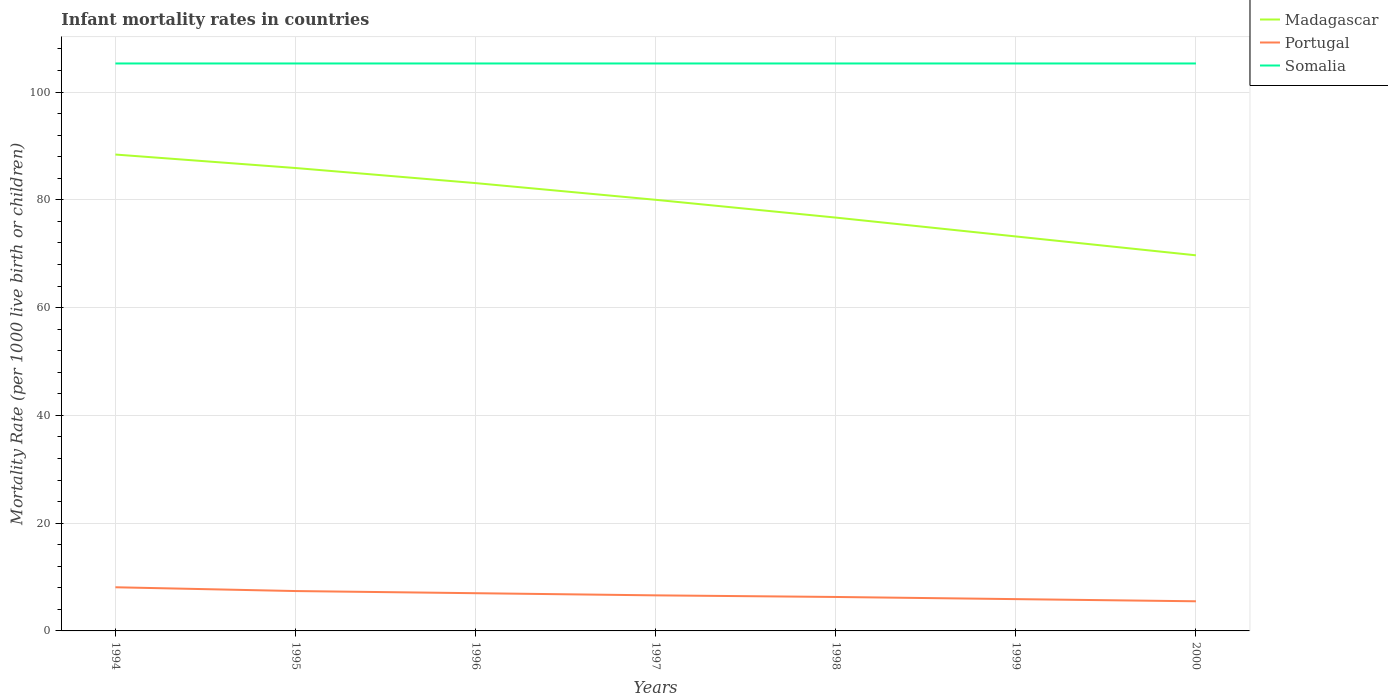Does the line corresponding to Somalia intersect with the line corresponding to Portugal?
Make the answer very short. No. Is the number of lines equal to the number of legend labels?
Offer a very short reply. Yes. In which year was the infant mortality rate in Madagascar maximum?
Give a very brief answer. 2000. What is the total infant mortality rate in Madagascar in the graph?
Ensure brevity in your answer.  6.4. What is the difference between the highest and the second highest infant mortality rate in Madagascar?
Your response must be concise. 18.7. What is the difference between the highest and the lowest infant mortality rate in Madagascar?
Ensure brevity in your answer.  4. How many lines are there?
Your answer should be very brief. 3. How many years are there in the graph?
Your answer should be very brief. 7. Does the graph contain any zero values?
Provide a succinct answer. No. Does the graph contain grids?
Your answer should be very brief. Yes. How are the legend labels stacked?
Make the answer very short. Vertical. What is the title of the graph?
Provide a succinct answer. Infant mortality rates in countries. What is the label or title of the X-axis?
Your response must be concise. Years. What is the label or title of the Y-axis?
Offer a very short reply. Mortality Rate (per 1000 live birth or children). What is the Mortality Rate (per 1000 live birth or children) of Madagascar in 1994?
Make the answer very short. 88.4. What is the Mortality Rate (per 1000 live birth or children) of Portugal in 1994?
Your answer should be compact. 8.1. What is the Mortality Rate (per 1000 live birth or children) of Somalia in 1994?
Offer a very short reply. 105.3. What is the Mortality Rate (per 1000 live birth or children) in Madagascar in 1995?
Your response must be concise. 85.9. What is the Mortality Rate (per 1000 live birth or children) of Portugal in 1995?
Your response must be concise. 7.4. What is the Mortality Rate (per 1000 live birth or children) in Somalia in 1995?
Your answer should be compact. 105.3. What is the Mortality Rate (per 1000 live birth or children) in Madagascar in 1996?
Your answer should be compact. 83.1. What is the Mortality Rate (per 1000 live birth or children) of Somalia in 1996?
Make the answer very short. 105.3. What is the Mortality Rate (per 1000 live birth or children) of Madagascar in 1997?
Make the answer very short. 80. What is the Mortality Rate (per 1000 live birth or children) in Somalia in 1997?
Give a very brief answer. 105.3. What is the Mortality Rate (per 1000 live birth or children) of Madagascar in 1998?
Offer a very short reply. 76.7. What is the Mortality Rate (per 1000 live birth or children) of Somalia in 1998?
Provide a succinct answer. 105.3. What is the Mortality Rate (per 1000 live birth or children) of Madagascar in 1999?
Provide a succinct answer. 73.2. What is the Mortality Rate (per 1000 live birth or children) in Portugal in 1999?
Your answer should be compact. 5.9. What is the Mortality Rate (per 1000 live birth or children) of Somalia in 1999?
Provide a short and direct response. 105.3. What is the Mortality Rate (per 1000 live birth or children) in Madagascar in 2000?
Provide a short and direct response. 69.7. What is the Mortality Rate (per 1000 live birth or children) of Somalia in 2000?
Provide a short and direct response. 105.3. Across all years, what is the maximum Mortality Rate (per 1000 live birth or children) in Madagascar?
Keep it short and to the point. 88.4. Across all years, what is the maximum Mortality Rate (per 1000 live birth or children) in Somalia?
Your answer should be very brief. 105.3. Across all years, what is the minimum Mortality Rate (per 1000 live birth or children) in Madagascar?
Make the answer very short. 69.7. Across all years, what is the minimum Mortality Rate (per 1000 live birth or children) of Somalia?
Your response must be concise. 105.3. What is the total Mortality Rate (per 1000 live birth or children) of Madagascar in the graph?
Your response must be concise. 557. What is the total Mortality Rate (per 1000 live birth or children) of Portugal in the graph?
Keep it short and to the point. 46.8. What is the total Mortality Rate (per 1000 live birth or children) of Somalia in the graph?
Provide a short and direct response. 737.1. What is the difference between the Mortality Rate (per 1000 live birth or children) of Somalia in 1994 and that in 1997?
Provide a succinct answer. 0. What is the difference between the Mortality Rate (per 1000 live birth or children) in Portugal in 1994 and that in 1998?
Ensure brevity in your answer.  1.8. What is the difference between the Mortality Rate (per 1000 live birth or children) of Somalia in 1994 and that in 1998?
Ensure brevity in your answer.  0. What is the difference between the Mortality Rate (per 1000 live birth or children) in Portugal in 1994 and that in 2000?
Give a very brief answer. 2.6. What is the difference between the Mortality Rate (per 1000 live birth or children) of Madagascar in 1995 and that in 1996?
Ensure brevity in your answer.  2.8. What is the difference between the Mortality Rate (per 1000 live birth or children) in Portugal in 1995 and that in 1996?
Your response must be concise. 0.4. What is the difference between the Mortality Rate (per 1000 live birth or children) of Somalia in 1995 and that in 1996?
Your answer should be compact. 0. What is the difference between the Mortality Rate (per 1000 live birth or children) of Portugal in 1995 and that in 1997?
Ensure brevity in your answer.  0.8. What is the difference between the Mortality Rate (per 1000 live birth or children) of Somalia in 1995 and that in 1998?
Your response must be concise. 0. What is the difference between the Mortality Rate (per 1000 live birth or children) in Madagascar in 1995 and that in 1999?
Your answer should be compact. 12.7. What is the difference between the Mortality Rate (per 1000 live birth or children) of Portugal in 1995 and that in 1999?
Make the answer very short. 1.5. What is the difference between the Mortality Rate (per 1000 live birth or children) in Portugal in 1996 and that in 1997?
Your response must be concise. 0.4. What is the difference between the Mortality Rate (per 1000 live birth or children) in Portugal in 1996 and that in 1998?
Ensure brevity in your answer.  0.7. What is the difference between the Mortality Rate (per 1000 live birth or children) of Portugal in 1996 and that in 1999?
Make the answer very short. 1.1. What is the difference between the Mortality Rate (per 1000 live birth or children) in Madagascar in 1996 and that in 2000?
Give a very brief answer. 13.4. What is the difference between the Mortality Rate (per 1000 live birth or children) in Portugal in 1996 and that in 2000?
Provide a succinct answer. 1.5. What is the difference between the Mortality Rate (per 1000 live birth or children) of Portugal in 1997 and that in 1998?
Keep it short and to the point. 0.3. What is the difference between the Mortality Rate (per 1000 live birth or children) in Madagascar in 1997 and that in 1999?
Your response must be concise. 6.8. What is the difference between the Mortality Rate (per 1000 live birth or children) of Portugal in 1997 and that in 1999?
Provide a succinct answer. 0.7. What is the difference between the Mortality Rate (per 1000 live birth or children) of Somalia in 1997 and that in 1999?
Offer a very short reply. 0. What is the difference between the Mortality Rate (per 1000 live birth or children) of Madagascar in 1997 and that in 2000?
Your answer should be compact. 10.3. What is the difference between the Mortality Rate (per 1000 live birth or children) of Portugal in 1997 and that in 2000?
Your answer should be very brief. 1.1. What is the difference between the Mortality Rate (per 1000 live birth or children) of Portugal in 1998 and that in 1999?
Keep it short and to the point. 0.4. What is the difference between the Mortality Rate (per 1000 live birth or children) in Portugal in 1998 and that in 2000?
Your response must be concise. 0.8. What is the difference between the Mortality Rate (per 1000 live birth or children) of Somalia in 1998 and that in 2000?
Keep it short and to the point. 0. What is the difference between the Mortality Rate (per 1000 live birth or children) in Madagascar in 1999 and that in 2000?
Offer a very short reply. 3.5. What is the difference between the Mortality Rate (per 1000 live birth or children) in Somalia in 1999 and that in 2000?
Give a very brief answer. 0. What is the difference between the Mortality Rate (per 1000 live birth or children) of Madagascar in 1994 and the Mortality Rate (per 1000 live birth or children) of Portugal in 1995?
Ensure brevity in your answer.  81. What is the difference between the Mortality Rate (per 1000 live birth or children) of Madagascar in 1994 and the Mortality Rate (per 1000 live birth or children) of Somalia in 1995?
Ensure brevity in your answer.  -16.9. What is the difference between the Mortality Rate (per 1000 live birth or children) of Portugal in 1994 and the Mortality Rate (per 1000 live birth or children) of Somalia in 1995?
Your response must be concise. -97.2. What is the difference between the Mortality Rate (per 1000 live birth or children) of Madagascar in 1994 and the Mortality Rate (per 1000 live birth or children) of Portugal in 1996?
Offer a terse response. 81.4. What is the difference between the Mortality Rate (per 1000 live birth or children) in Madagascar in 1994 and the Mortality Rate (per 1000 live birth or children) in Somalia in 1996?
Give a very brief answer. -16.9. What is the difference between the Mortality Rate (per 1000 live birth or children) in Portugal in 1994 and the Mortality Rate (per 1000 live birth or children) in Somalia in 1996?
Offer a very short reply. -97.2. What is the difference between the Mortality Rate (per 1000 live birth or children) of Madagascar in 1994 and the Mortality Rate (per 1000 live birth or children) of Portugal in 1997?
Offer a very short reply. 81.8. What is the difference between the Mortality Rate (per 1000 live birth or children) in Madagascar in 1994 and the Mortality Rate (per 1000 live birth or children) in Somalia in 1997?
Your answer should be compact. -16.9. What is the difference between the Mortality Rate (per 1000 live birth or children) in Portugal in 1994 and the Mortality Rate (per 1000 live birth or children) in Somalia in 1997?
Your answer should be compact. -97.2. What is the difference between the Mortality Rate (per 1000 live birth or children) of Madagascar in 1994 and the Mortality Rate (per 1000 live birth or children) of Portugal in 1998?
Your answer should be compact. 82.1. What is the difference between the Mortality Rate (per 1000 live birth or children) of Madagascar in 1994 and the Mortality Rate (per 1000 live birth or children) of Somalia in 1998?
Ensure brevity in your answer.  -16.9. What is the difference between the Mortality Rate (per 1000 live birth or children) in Portugal in 1994 and the Mortality Rate (per 1000 live birth or children) in Somalia in 1998?
Offer a terse response. -97.2. What is the difference between the Mortality Rate (per 1000 live birth or children) of Madagascar in 1994 and the Mortality Rate (per 1000 live birth or children) of Portugal in 1999?
Offer a terse response. 82.5. What is the difference between the Mortality Rate (per 1000 live birth or children) of Madagascar in 1994 and the Mortality Rate (per 1000 live birth or children) of Somalia in 1999?
Provide a short and direct response. -16.9. What is the difference between the Mortality Rate (per 1000 live birth or children) of Portugal in 1994 and the Mortality Rate (per 1000 live birth or children) of Somalia in 1999?
Ensure brevity in your answer.  -97.2. What is the difference between the Mortality Rate (per 1000 live birth or children) of Madagascar in 1994 and the Mortality Rate (per 1000 live birth or children) of Portugal in 2000?
Offer a terse response. 82.9. What is the difference between the Mortality Rate (per 1000 live birth or children) of Madagascar in 1994 and the Mortality Rate (per 1000 live birth or children) of Somalia in 2000?
Your response must be concise. -16.9. What is the difference between the Mortality Rate (per 1000 live birth or children) of Portugal in 1994 and the Mortality Rate (per 1000 live birth or children) of Somalia in 2000?
Your answer should be very brief. -97.2. What is the difference between the Mortality Rate (per 1000 live birth or children) in Madagascar in 1995 and the Mortality Rate (per 1000 live birth or children) in Portugal in 1996?
Offer a terse response. 78.9. What is the difference between the Mortality Rate (per 1000 live birth or children) of Madagascar in 1995 and the Mortality Rate (per 1000 live birth or children) of Somalia in 1996?
Your answer should be very brief. -19.4. What is the difference between the Mortality Rate (per 1000 live birth or children) in Portugal in 1995 and the Mortality Rate (per 1000 live birth or children) in Somalia in 1996?
Your answer should be very brief. -97.9. What is the difference between the Mortality Rate (per 1000 live birth or children) in Madagascar in 1995 and the Mortality Rate (per 1000 live birth or children) in Portugal in 1997?
Provide a succinct answer. 79.3. What is the difference between the Mortality Rate (per 1000 live birth or children) of Madagascar in 1995 and the Mortality Rate (per 1000 live birth or children) of Somalia in 1997?
Offer a very short reply. -19.4. What is the difference between the Mortality Rate (per 1000 live birth or children) in Portugal in 1995 and the Mortality Rate (per 1000 live birth or children) in Somalia in 1997?
Provide a short and direct response. -97.9. What is the difference between the Mortality Rate (per 1000 live birth or children) in Madagascar in 1995 and the Mortality Rate (per 1000 live birth or children) in Portugal in 1998?
Offer a very short reply. 79.6. What is the difference between the Mortality Rate (per 1000 live birth or children) in Madagascar in 1995 and the Mortality Rate (per 1000 live birth or children) in Somalia in 1998?
Make the answer very short. -19.4. What is the difference between the Mortality Rate (per 1000 live birth or children) in Portugal in 1995 and the Mortality Rate (per 1000 live birth or children) in Somalia in 1998?
Provide a succinct answer. -97.9. What is the difference between the Mortality Rate (per 1000 live birth or children) of Madagascar in 1995 and the Mortality Rate (per 1000 live birth or children) of Portugal in 1999?
Provide a short and direct response. 80. What is the difference between the Mortality Rate (per 1000 live birth or children) in Madagascar in 1995 and the Mortality Rate (per 1000 live birth or children) in Somalia in 1999?
Your response must be concise. -19.4. What is the difference between the Mortality Rate (per 1000 live birth or children) in Portugal in 1995 and the Mortality Rate (per 1000 live birth or children) in Somalia in 1999?
Provide a succinct answer. -97.9. What is the difference between the Mortality Rate (per 1000 live birth or children) of Madagascar in 1995 and the Mortality Rate (per 1000 live birth or children) of Portugal in 2000?
Give a very brief answer. 80.4. What is the difference between the Mortality Rate (per 1000 live birth or children) in Madagascar in 1995 and the Mortality Rate (per 1000 live birth or children) in Somalia in 2000?
Give a very brief answer. -19.4. What is the difference between the Mortality Rate (per 1000 live birth or children) in Portugal in 1995 and the Mortality Rate (per 1000 live birth or children) in Somalia in 2000?
Provide a short and direct response. -97.9. What is the difference between the Mortality Rate (per 1000 live birth or children) in Madagascar in 1996 and the Mortality Rate (per 1000 live birth or children) in Portugal in 1997?
Ensure brevity in your answer.  76.5. What is the difference between the Mortality Rate (per 1000 live birth or children) in Madagascar in 1996 and the Mortality Rate (per 1000 live birth or children) in Somalia in 1997?
Your response must be concise. -22.2. What is the difference between the Mortality Rate (per 1000 live birth or children) in Portugal in 1996 and the Mortality Rate (per 1000 live birth or children) in Somalia in 1997?
Give a very brief answer. -98.3. What is the difference between the Mortality Rate (per 1000 live birth or children) of Madagascar in 1996 and the Mortality Rate (per 1000 live birth or children) of Portugal in 1998?
Your answer should be very brief. 76.8. What is the difference between the Mortality Rate (per 1000 live birth or children) in Madagascar in 1996 and the Mortality Rate (per 1000 live birth or children) in Somalia in 1998?
Provide a short and direct response. -22.2. What is the difference between the Mortality Rate (per 1000 live birth or children) in Portugal in 1996 and the Mortality Rate (per 1000 live birth or children) in Somalia in 1998?
Your answer should be compact. -98.3. What is the difference between the Mortality Rate (per 1000 live birth or children) in Madagascar in 1996 and the Mortality Rate (per 1000 live birth or children) in Portugal in 1999?
Give a very brief answer. 77.2. What is the difference between the Mortality Rate (per 1000 live birth or children) in Madagascar in 1996 and the Mortality Rate (per 1000 live birth or children) in Somalia in 1999?
Make the answer very short. -22.2. What is the difference between the Mortality Rate (per 1000 live birth or children) of Portugal in 1996 and the Mortality Rate (per 1000 live birth or children) of Somalia in 1999?
Your answer should be compact. -98.3. What is the difference between the Mortality Rate (per 1000 live birth or children) in Madagascar in 1996 and the Mortality Rate (per 1000 live birth or children) in Portugal in 2000?
Make the answer very short. 77.6. What is the difference between the Mortality Rate (per 1000 live birth or children) of Madagascar in 1996 and the Mortality Rate (per 1000 live birth or children) of Somalia in 2000?
Your answer should be compact. -22.2. What is the difference between the Mortality Rate (per 1000 live birth or children) in Portugal in 1996 and the Mortality Rate (per 1000 live birth or children) in Somalia in 2000?
Ensure brevity in your answer.  -98.3. What is the difference between the Mortality Rate (per 1000 live birth or children) of Madagascar in 1997 and the Mortality Rate (per 1000 live birth or children) of Portugal in 1998?
Ensure brevity in your answer.  73.7. What is the difference between the Mortality Rate (per 1000 live birth or children) of Madagascar in 1997 and the Mortality Rate (per 1000 live birth or children) of Somalia in 1998?
Keep it short and to the point. -25.3. What is the difference between the Mortality Rate (per 1000 live birth or children) in Portugal in 1997 and the Mortality Rate (per 1000 live birth or children) in Somalia in 1998?
Offer a terse response. -98.7. What is the difference between the Mortality Rate (per 1000 live birth or children) of Madagascar in 1997 and the Mortality Rate (per 1000 live birth or children) of Portugal in 1999?
Your answer should be compact. 74.1. What is the difference between the Mortality Rate (per 1000 live birth or children) of Madagascar in 1997 and the Mortality Rate (per 1000 live birth or children) of Somalia in 1999?
Offer a terse response. -25.3. What is the difference between the Mortality Rate (per 1000 live birth or children) of Portugal in 1997 and the Mortality Rate (per 1000 live birth or children) of Somalia in 1999?
Offer a very short reply. -98.7. What is the difference between the Mortality Rate (per 1000 live birth or children) in Madagascar in 1997 and the Mortality Rate (per 1000 live birth or children) in Portugal in 2000?
Your answer should be very brief. 74.5. What is the difference between the Mortality Rate (per 1000 live birth or children) of Madagascar in 1997 and the Mortality Rate (per 1000 live birth or children) of Somalia in 2000?
Offer a very short reply. -25.3. What is the difference between the Mortality Rate (per 1000 live birth or children) in Portugal in 1997 and the Mortality Rate (per 1000 live birth or children) in Somalia in 2000?
Your answer should be compact. -98.7. What is the difference between the Mortality Rate (per 1000 live birth or children) in Madagascar in 1998 and the Mortality Rate (per 1000 live birth or children) in Portugal in 1999?
Offer a very short reply. 70.8. What is the difference between the Mortality Rate (per 1000 live birth or children) in Madagascar in 1998 and the Mortality Rate (per 1000 live birth or children) in Somalia in 1999?
Offer a terse response. -28.6. What is the difference between the Mortality Rate (per 1000 live birth or children) in Portugal in 1998 and the Mortality Rate (per 1000 live birth or children) in Somalia in 1999?
Offer a terse response. -99. What is the difference between the Mortality Rate (per 1000 live birth or children) of Madagascar in 1998 and the Mortality Rate (per 1000 live birth or children) of Portugal in 2000?
Give a very brief answer. 71.2. What is the difference between the Mortality Rate (per 1000 live birth or children) in Madagascar in 1998 and the Mortality Rate (per 1000 live birth or children) in Somalia in 2000?
Your answer should be compact. -28.6. What is the difference between the Mortality Rate (per 1000 live birth or children) of Portugal in 1998 and the Mortality Rate (per 1000 live birth or children) of Somalia in 2000?
Your response must be concise. -99. What is the difference between the Mortality Rate (per 1000 live birth or children) of Madagascar in 1999 and the Mortality Rate (per 1000 live birth or children) of Portugal in 2000?
Offer a terse response. 67.7. What is the difference between the Mortality Rate (per 1000 live birth or children) of Madagascar in 1999 and the Mortality Rate (per 1000 live birth or children) of Somalia in 2000?
Your answer should be very brief. -32.1. What is the difference between the Mortality Rate (per 1000 live birth or children) in Portugal in 1999 and the Mortality Rate (per 1000 live birth or children) in Somalia in 2000?
Your answer should be compact. -99.4. What is the average Mortality Rate (per 1000 live birth or children) in Madagascar per year?
Make the answer very short. 79.57. What is the average Mortality Rate (per 1000 live birth or children) of Portugal per year?
Your answer should be compact. 6.69. What is the average Mortality Rate (per 1000 live birth or children) of Somalia per year?
Provide a short and direct response. 105.3. In the year 1994, what is the difference between the Mortality Rate (per 1000 live birth or children) of Madagascar and Mortality Rate (per 1000 live birth or children) of Portugal?
Keep it short and to the point. 80.3. In the year 1994, what is the difference between the Mortality Rate (per 1000 live birth or children) in Madagascar and Mortality Rate (per 1000 live birth or children) in Somalia?
Ensure brevity in your answer.  -16.9. In the year 1994, what is the difference between the Mortality Rate (per 1000 live birth or children) of Portugal and Mortality Rate (per 1000 live birth or children) of Somalia?
Keep it short and to the point. -97.2. In the year 1995, what is the difference between the Mortality Rate (per 1000 live birth or children) in Madagascar and Mortality Rate (per 1000 live birth or children) in Portugal?
Keep it short and to the point. 78.5. In the year 1995, what is the difference between the Mortality Rate (per 1000 live birth or children) of Madagascar and Mortality Rate (per 1000 live birth or children) of Somalia?
Ensure brevity in your answer.  -19.4. In the year 1995, what is the difference between the Mortality Rate (per 1000 live birth or children) in Portugal and Mortality Rate (per 1000 live birth or children) in Somalia?
Offer a terse response. -97.9. In the year 1996, what is the difference between the Mortality Rate (per 1000 live birth or children) of Madagascar and Mortality Rate (per 1000 live birth or children) of Portugal?
Offer a very short reply. 76.1. In the year 1996, what is the difference between the Mortality Rate (per 1000 live birth or children) of Madagascar and Mortality Rate (per 1000 live birth or children) of Somalia?
Give a very brief answer. -22.2. In the year 1996, what is the difference between the Mortality Rate (per 1000 live birth or children) of Portugal and Mortality Rate (per 1000 live birth or children) of Somalia?
Provide a short and direct response. -98.3. In the year 1997, what is the difference between the Mortality Rate (per 1000 live birth or children) of Madagascar and Mortality Rate (per 1000 live birth or children) of Portugal?
Your answer should be compact. 73.4. In the year 1997, what is the difference between the Mortality Rate (per 1000 live birth or children) of Madagascar and Mortality Rate (per 1000 live birth or children) of Somalia?
Make the answer very short. -25.3. In the year 1997, what is the difference between the Mortality Rate (per 1000 live birth or children) of Portugal and Mortality Rate (per 1000 live birth or children) of Somalia?
Your answer should be very brief. -98.7. In the year 1998, what is the difference between the Mortality Rate (per 1000 live birth or children) in Madagascar and Mortality Rate (per 1000 live birth or children) in Portugal?
Provide a short and direct response. 70.4. In the year 1998, what is the difference between the Mortality Rate (per 1000 live birth or children) in Madagascar and Mortality Rate (per 1000 live birth or children) in Somalia?
Offer a terse response. -28.6. In the year 1998, what is the difference between the Mortality Rate (per 1000 live birth or children) in Portugal and Mortality Rate (per 1000 live birth or children) in Somalia?
Offer a terse response. -99. In the year 1999, what is the difference between the Mortality Rate (per 1000 live birth or children) in Madagascar and Mortality Rate (per 1000 live birth or children) in Portugal?
Provide a succinct answer. 67.3. In the year 1999, what is the difference between the Mortality Rate (per 1000 live birth or children) of Madagascar and Mortality Rate (per 1000 live birth or children) of Somalia?
Make the answer very short. -32.1. In the year 1999, what is the difference between the Mortality Rate (per 1000 live birth or children) in Portugal and Mortality Rate (per 1000 live birth or children) in Somalia?
Offer a very short reply. -99.4. In the year 2000, what is the difference between the Mortality Rate (per 1000 live birth or children) of Madagascar and Mortality Rate (per 1000 live birth or children) of Portugal?
Provide a short and direct response. 64.2. In the year 2000, what is the difference between the Mortality Rate (per 1000 live birth or children) in Madagascar and Mortality Rate (per 1000 live birth or children) in Somalia?
Make the answer very short. -35.6. In the year 2000, what is the difference between the Mortality Rate (per 1000 live birth or children) of Portugal and Mortality Rate (per 1000 live birth or children) of Somalia?
Offer a terse response. -99.8. What is the ratio of the Mortality Rate (per 1000 live birth or children) of Madagascar in 1994 to that in 1995?
Your response must be concise. 1.03. What is the ratio of the Mortality Rate (per 1000 live birth or children) of Portugal in 1994 to that in 1995?
Ensure brevity in your answer.  1.09. What is the ratio of the Mortality Rate (per 1000 live birth or children) of Somalia in 1994 to that in 1995?
Provide a short and direct response. 1. What is the ratio of the Mortality Rate (per 1000 live birth or children) in Madagascar in 1994 to that in 1996?
Ensure brevity in your answer.  1.06. What is the ratio of the Mortality Rate (per 1000 live birth or children) of Portugal in 1994 to that in 1996?
Ensure brevity in your answer.  1.16. What is the ratio of the Mortality Rate (per 1000 live birth or children) in Madagascar in 1994 to that in 1997?
Your answer should be compact. 1.1. What is the ratio of the Mortality Rate (per 1000 live birth or children) of Portugal in 1994 to that in 1997?
Offer a very short reply. 1.23. What is the ratio of the Mortality Rate (per 1000 live birth or children) of Somalia in 1994 to that in 1997?
Make the answer very short. 1. What is the ratio of the Mortality Rate (per 1000 live birth or children) of Madagascar in 1994 to that in 1998?
Your answer should be very brief. 1.15. What is the ratio of the Mortality Rate (per 1000 live birth or children) in Madagascar in 1994 to that in 1999?
Provide a short and direct response. 1.21. What is the ratio of the Mortality Rate (per 1000 live birth or children) in Portugal in 1994 to that in 1999?
Offer a terse response. 1.37. What is the ratio of the Mortality Rate (per 1000 live birth or children) of Somalia in 1994 to that in 1999?
Offer a very short reply. 1. What is the ratio of the Mortality Rate (per 1000 live birth or children) of Madagascar in 1994 to that in 2000?
Your answer should be compact. 1.27. What is the ratio of the Mortality Rate (per 1000 live birth or children) in Portugal in 1994 to that in 2000?
Your answer should be very brief. 1.47. What is the ratio of the Mortality Rate (per 1000 live birth or children) of Madagascar in 1995 to that in 1996?
Give a very brief answer. 1.03. What is the ratio of the Mortality Rate (per 1000 live birth or children) in Portugal in 1995 to that in 1996?
Provide a short and direct response. 1.06. What is the ratio of the Mortality Rate (per 1000 live birth or children) of Somalia in 1995 to that in 1996?
Your answer should be very brief. 1. What is the ratio of the Mortality Rate (per 1000 live birth or children) in Madagascar in 1995 to that in 1997?
Offer a very short reply. 1.07. What is the ratio of the Mortality Rate (per 1000 live birth or children) in Portugal in 1995 to that in 1997?
Your response must be concise. 1.12. What is the ratio of the Mortality Rate (per 1000 live birth or children) in Somalia in 1995 to that in 1997?
Provide a short and direct response. 1. What is the ratio of the Mortality Rate (per 1000 live birth or children) of Madagascar in 1995 to that in 1998?
Ensure brevity in your answer.  1.12. What is the ratio of the Mortality Rate (per 1000 live birth or children) of Portugal in 1995 to that in 1998?
Give a very brief answer. 1.17. What is the ratio of the Mortality Rate (per 1000 live birth or children) of Madagascar in 1995 to that in 1999?
Your answer should be compact. 1.17. What is the ratio of the Mortality Rate (per 1000 live birth or children) in Portugal in 1995 to that in 1999?
Keep it short and to the point. 1.25. What is the ratio of the Mortality Rate (per 1000 live birth or children) of Somalia in 1995 to that in 1999?
Your response must be concise. 1. What is the ratio of the Mortality Rate (per 1000 live birth or children) in Madagascar in 1995 to that in 2000?
Make the answer very short. 1.23. What is the ratio of the Mortality Rate (per 1000 live birth or children) in Portugal in 1995 to that in 2000?
Your answer should be very brief. 1.35. What is the ratio of the Mortality Rate (per 1000 live birth or children) of Somalia in 1995 to that in 2000?
Your response must be concise. 1. What is the ratio of the Mortality Rate (per 1000 live birth or children) of Madagascar in 1996 to that in 1997?
Provide a succinct answer. 1.04. What is the ratio of the Mortality Rate (per 1000 live birth or children) in Portugal in 1996 to that in 1997?
Your answer should be compact. 1.06. What is the ratio of the Mortality Rate (per 1000 live birth or children) in Somalia in 1996 to that in 1997?
Make the answer very short. 1. What is the ratio of the Mortality Rate (per 1000 live birth or children) in Madagascar in 1996 to that in 1998?
Make the answer very short. 1.08. What is the ratio of the Mortality Rate (per 1000 live birth or children) of Portugal in 1996 to that in 1998?
Provide a succinct answer. 1.11. What is the ratio of the Mortality Rate (per 1000 live birth or children) in Somalia in 1996 to that in 1998?
Your response must be concise. 1. What is the ratio of the Mortality Rate (per 1000 live birth or children) of Madagascar in 1996 to that in 1999?
Your answer should be compact. 1.14. What is the ratio of the Mortality Rate (per 1000 live birth or children) in Portugal in 1996 to that in 1999?
Your answer should be very brief. 1.19. What is the ratio of the Mortality Rate (per 1000 live birth or children) of Madagascar in 1996 to that in 2000?
Your response must be concise. 1.19. What is the ratio of the Mortality Rate (per 1000 live birth or children) in Portugal in 1996 to that in 2000?
Offer a very short reply. 1.27. What is the ratio of the Mortality Rate (per 1000 live birth or children) of Madagascar in 1997 to that in 1998?
Provide a short and direct response. 1.04. What is the ratio of the Mortality Rate (per 1000 live birth or children) in Portugal in 1997 to that in 1998?
Offer a terse response. 1.05. What is the ratio of the Mortality Rate (per 1000 live birth or children) of Somalia in 1997 to that in 1998?
Offer a very short reply. 1. What is the ratio of the Mortality Rate (per 1000 live birth or children) of Madagascar in 1997 to that in 1999?
Ensure brevity in your answer.  1.09. What is the ratio of the Mortality Rate (per 1000 live birth or children) of Portugal in 1997 to that in 1999?
Give a very brief answer. 1.12. What is the ratio of the Mortality Rate (per 1000 live birth or children) of Madagascar in 1997 to that in 2000?
Your answer should be compact. 1.15. What is the ratio of the Mortality Rate (per 1000 live birth or children) in Madagascar in 1998 to that in 1999?
Give a very brief answer. 1.05. What is the ratio of the Mortality Rate (per 1000 live birth or children) of Portugal in 1998 to that in 1999?
Offer a very short reply. 1.07. What is the ratio of the Mortality Rate (per 1000 live birth or children) of Madagascar in 1998 to that in 2000?
Make the answer very short. 1.1. What is the ratio of the Mortality Rate (per 1000 live birth or children) in Portugal in 1998 to that in 2000?
Your answer should be compact. 1.15. What is the ratio of the Mortality Rate (per 1000 live birth or children) in Madagascar in 1999 to that in 2000?
Your answer should be very brief. 1.05. What is the ratio of the Mortality Rate (per 1000 live birth or children) in Portugal in 1999 to that in 2000?
Offer a terse response. 1.07. What is the difference between the highest and the second highest Mortality Rate (per 1000 live birth or children) in Portugal?
Your response must be concise. 0.7. What is the difference between the highest and the second highest Mortality Rate (per 1000 live birth or children) in Somalia?
Make the answer very short. 0. What is the difference between the highest and the lowest Mortality Rate (per 1000 live birth or children) in Somalia?
Make the answer very short. 0. 